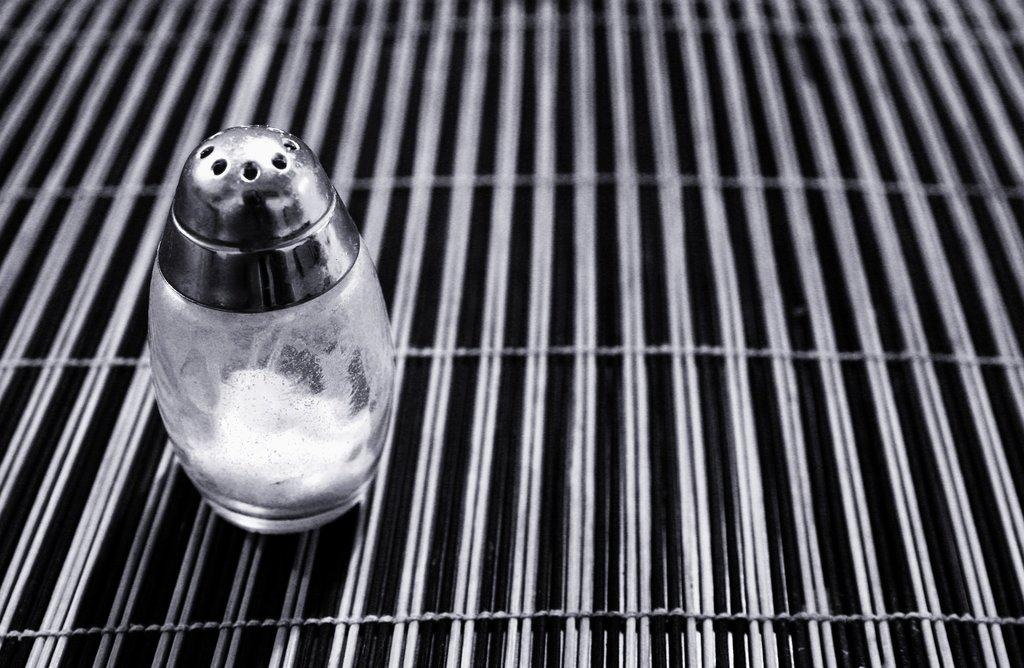What object can be seen in the image? There is a salt shaker in the image. Where is the salt shaker located? The salt shaker is on a grill surface. What type of bait is being used on the grill in the image? There is no bait present in the image; it only features a salt shaker on a grill surface. 